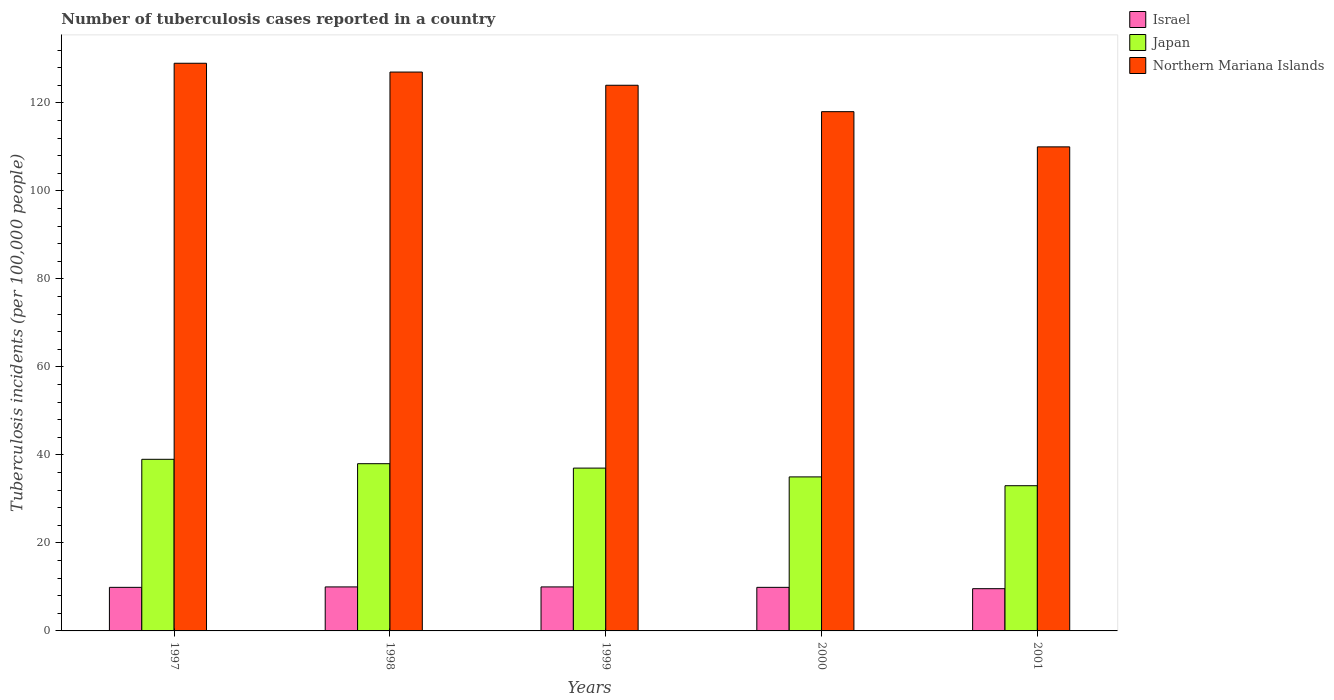How many groups of bars are there?
Provide a succinct answer. 5. Are the number of bars per tick equal to the number of legend labels?
Make the answer very short. Yes. How many bars are there on the 2nd tick from the left?
Your response must be concise. 3. What is the label of the 4th group of bars from the left?
Ensure brevity in your answer.  2000. What is the number of tuberculosis cases reported in in Japan in 1999?
Provide a short and direct response. 37. Across all years, what is the maximum number of tuberculosis cases reported in in Israel?
Provide a short and direct response. 10. Across all years, what is the minimum number of tuberculosis cases reported in in Japan?
Your response must be concise. 33. In which year was the number of tuberculosis cases reported in in Northern Mariana Islands maximum?
Keep it short and to the point. 1997. In which year was the number of tuberculosis cases reported in in Japan minimum?
Give a very brief answer. 2001. What is the total number of tuberculosis cases reported in in Israel in the graph?
Your answer should be compact. 49.4. What is the difference between the number of tuberculosis cases reported in in Northern Mariana Islands in 1997 and that in 1999?
Keep it short and to the point. 5. What is the difference between the number of tuberculosis cases reported in in Japan in 2000 and the number of tuberculosis cases reported in in Northern Mariana Islands in 2001?
Ensure brevity in your answer.  -75. What is the average number of tuberculosis cases reported in in Japan per year?
Offer a terse response. 36.4. In the year 2001, what is the difference between the number of tuberculosis cases reported in in Israel and number of tuberculosis cases reported in in Japan?
Your response must be concise. -23.4. What is the ratio of the number of tuberculosis cases reported in in Japan in 1997 to that in 2001?
Your answer should be compact. 1.18. Is the difference between the number of tuberculosis cases reported in in Israel in 1999 and 2001 greater than the difference between the number of tuberculosis cases reported in in Japan in 1999 and 2001?
Offer a terse response. No. What is the difference between the highest and the second highest number of tuberculosis cases reported in in Japan?
Provide a short and direct response. 1. What is the difference between the highest and the lowest number of tuberculosis cases reported in in Israel?
Offer a very short reply. 0.4. How many bars are there?
Provide a short and direct response. 15. What is the difference between two consecutive major ticks on the Y-axis?
Provide a succinct answer. 20. Where does the legend appear in the graph?
Your response must be concise. Top right. How many legend labels are there?
Provide a short and direct response. 3. How are the legend labels stacked?
Offer a terse response. Vertical. What is the title of the graph?
Provide a short and direct response. Number of tuberculosis cases reported in a country. Does "Caribbean small states" appear as one of the legend labels in the graph?
Make the answer very short. No. What is the label or title of the Y-axis?
Offer a terse response. Tuberculosis incidents (per 100,0 people). What is the Tuberculosis incidents (per 100,000 people) of Israel in 1997?
Your response must be concise. 9.9. What is the Tuberculosis incidents (per 100,000 people) of Japan in 1997?
Provide a short and direct response. 39. What is the Tuberculosis incidents (per 100,000 people) in Northern Mariana Islands in 1997?
Offer a terse response. 129. What is the Tuberculosis incidents (per 100,000 people) in Israel in 1998?
Make the answer very short. 10. What is the Tuberculosis incidents (per 100,000 people) in Northern Mariana Islands in 1998?
Offer a very short reply. 127. What is the Tuberculosis incidents (per 100,000 people) of Japan in 1999?
Offer a very short reply. 37. What is the Tuberculosis incidents (per 100,000 people) in Northern Mariana Islands in 1999?
Provide a succinct answer. 124. What is the Tuberculosis incidents (per 100,000 people) in Northern Mariana Islands in 2000?
Your answer should be very brief. 118. What is the Tuberculosis incidents (per 100,000 people) of Israel in 2001?
Offer a terse response. 9.6. What is the Tuberculosis incidents (per 100,000 people) of Northern Mariana Islands in 2001?
Give a very brief answer. 110. Across all years, what is the maximum Tuberculosis incidents (per 100,000 people) in Japan?
Keep it short and to the point. 39. Across all years, what is the maximum Tuberculosis incidents (per 100,000 people) of Northern Mariana Islands?
Provide a succinct answer. 129. Across all years, what is the minimum Tuberculosis incidents (per 100,000 people) in Israel?
Offer a terse response. 9.6. Across all years, what is the minimum Tuberculosis incidents (per 100,000 people) in Japan?
Your answer should be very brief. 33. Across all years, what is the minimum Tuberculosis incidents (per 100,000 people) of Northern Mariana Islands?
Provide a succinct answer. 110. What is the total Tuberculosis incidents (per 100,000 people) in Israel in the graph?
Ensure brevity in your answer.  49.4. What is the total Tuberculosis incidents (per 100,000 people) of Japan in the graph?
Ensure brevity in your answer.  182. What is the total Tuberculosis incidents (per 100,000 people) in Northern Mariana Islands in the graph?
Provide a succinct answer. 608. What is the difference between the Tuberculosis incidents (per 100,000 people) in Israel in 1997 and that in 1998?
Make the answer very short. -0.1. What is the difference between the Tuberculosis incidents (per 100,000 people) of Northern Mariana Islands in 1997 and that in 1998?
Give a very brief answer. 2. What is the difference between the Tuberculosis incidents (per 100,000 people) in Israel in 1997 and that in 2000?
Provide a short and direct response. 0. What is the difference between the Tuberculosis incidents (per 100,000 people) of Japan in 1997 and that in 2000?
Your answer should be compact. 4. What is the difference between the Tuberculosis incidents (per 100,000 people) in Northern Mariana Islands in 1997 and that in 2000?
Offer a terse response. 11. What is the difference between the Tuberculosis incidents (per 100,000 people) in Israel in 1997 and that in 2001?
Provide a short and direct response. 0.3. What is the difference between the Tuberculosis incidents (per 100,000 people) in Japan in 1997 and that in 2001?
Give a very brief answer. 6. What is the difference between the Tuberculosis incidents (per 100,000 people) in Israel in 1998 and that in 1999?
Offer a terse response. 0. What is the difference between the Tuberculosis incidents (per 100,000 people) in Northern Mariana Islands in 1998 and that in 1999?
Offer a terse response. 3. What is the difference between the Tuberculosis incidents (per 100,000 people) in Israel in 1998 and that in 2000?
Ensure brevity in your answer.  0.1. What is the difference between the Tuberculosis incidents (per 100,000 people) in Israel in 1998 and that in 2001?
Make the answer very short. 0.4. What is the difference between the Tuberculosis incidents (per 100,000 people) of Japan in 1998 and that in 2001?
Keep it short and to the point. 5. What is the difference between the Tuberculosis incidents (per 100,000 people) of Israel in 1999 and that in 2001?
Your response must be concise. 0.4. What is the difference between the Tuberculosis incidents (per 100,000 people) of Japan in 1999 and that in 2001?
Offer a very short reply. 4. What is the difference between the Tuberculosis incidents (per 100,000 people) of Northern Mariana Islands in 1999 and that in 2001?
Your response must be concise. 14. What is the difference between the Tuberculosis incidents (per 100,000 people) in Northern Mariana Islands in 2000 and that in 2001?
Keep it short and to the point. 8. What is the difference between the Tuberculosis incidents (per 100,000 people) in Israel in 1997 and the Tuberculosis incidents (per 100,000 people) in Japan in 1998?
Ensure brevity in your answer.  -28.1. What is the difference between the Tuberculosis incidents (per 100,000 people) in Israel in 1997 and the Tuberculosis incidents (per 100,000 people) in Northern Mariana Islands in 1998?
Give a very brief answer. -117.1. What is the difference between the Tuberculosis incidents (per 100,000 people) in Japan in 1997 and the Tuberculosis incidents (per 100,000 people) in Northern Mariana Islands in 1998?
Your answer should be very brief. -88. What is the difference between the Tuberculosis incidents (per 100,000 people) in Israel in 1997 and the Tuberculosis incidents (per 100,000 people) in Japan in 1999?
Your response must be concise. -27.1. What is the difference between the Tuberculosis incidents (per 100,000 people) in Israel in 1997 and the Tuberculosis incidents (per 100,000 people) in Northern Mariana Islands in 1999?
Provide a short and direct response. -114.1. What is the difference between the Tuberculosis incidents (per 100,000 people) of Japan in 1997 and the Tuberculosis incidents (per 100,000 people) of Northern Mariana Islands in 1999?
Keep it short and to the point. -85. What is the difference between the Tuberculosis incidents (per 100,000 people) of Israel in 1997 and the Tuberculosis incidents (per 100,000 people) of Japan in 2000?
Provide a succinct answer. -25.1. What is the difference between the Tuberculosis incidents (per 100,000 people) in Israel in 1997 and the Tuberculosis incidents (per 100,000 people) in Northern Mariana Islands in 2000?
Offer a very short reply. -108.1. What is the difference between the Tuberculosis incidents (per 100,000 people) of Japan in 1997 and the Tuberculosis incidents (per 100,000 people) of Northern Mariana Islands in 2000?
Provide a short and direct response. -79. What is the difference between the Tuberculosis incidents (per 100,000 people) in Israel in 1997 and the Tuberculosis incidents (per 100,000 people) in Japan in 2001?
Offer a very short reply. -23.1. What is the difference between the Tuberculosis incidents (per 100,000 people) in Israel in 1997 and the Tuberculosis incidents (per 100,000 people) in Northern Mariana Islands in 2001?
Offer a terse response. -100.1. What is the difference between the Tuberculosis incidents (per 100,000 people) in Japan in 1997 and the Tuberculosis incidents (per 100,000 people) in Northern Mariana Islands in 2001?
Provide a short and direct response. -71. What is the difference between the Tuberculosis incidents (per 100,000 people) in Israel in 1998 and the Tuberculosis incidents (per 100,000 people) in Northern Mariana Islands in 1999?
Your response must be concise. -114. What is the difference between the Tuberculosis incidents (per 100,000 people) in Japan in 1998 and the Tuberculosis incidents (per 100,000 people) in Northern Mariana Islands in 1999?
Give a very brief answer. -86. What is the difference between the Tuberculosis incidents (per 100,000 people) in Israel in 1998 and the Tuberculosis incidents (per 100,000 people) in Northern Mariana Islands in 2000?
Your answer should be compact. -108. What is the difference between the Tuberculosis incidents (per 100,000 people) of Japan in 1998 and the Tuberculosis incidents (per 100,000 people) of Northern Mariana Islands in 2000?
Your response must be concise. -80. What is the difference between the Tuberculosis incidents (per 100,000 people) in Israel in 1998 and the Tuberculosis incidents (per 100,000 people) in Northern Mariana Islands in 2001?
Keep it short and to the point. -100. What is the difference between the Tuberculosis incidents (per 100,000 people) in Japan in 1998 and the Tuberculosis incidents (per 100,000 people) in Northern Mariana Islands in 2001?
Your answer should be very brief. -72. What is the difference between the Tuberculosis incidents (per 100,000 people) in Israel in 1999 and the Tuberculosis incidents (per 100,000 people) in Japan in 2000?
Make the answer very short. -25. What is the difference between the Tuberculosis incidents (per 100,000 people) of Israel in 1999 and the Tuberculosis incidents (per 100,000 people) of Northern Mariana Islands in 2000?
Provide a short and direct response. -108. What is the difference between the Tuberculosis incidents (per 100,000 people) in Japan in 1999 and the Tuberculosis incidents (per 100,000 people) in Northern Mariana Islands in 2000?
Provide a short and direct response. -81. What is the difference between the Tuberculosis incidents (per 100,000 people) in Israel in 1999 and the Tuberculosis incidents (per 100,000 people) in Northern Mariana Islands in 2001?
Your answer should be compact. -100. What is the difference between the Tuberculosis incidents (per 100,000 people) in Japan in 1999 and the Tuberculosis incidents (per 100,000 people) in Northern Mariana Islands in 2001?
Your answer should be compact. -73. What is the difference between the Tuberculosis incidents (per 100,000 people) in Israel in 2000 and the Tuberculosis incidents (per 100,000 people) in Japan in 2001?
Your answer should be very brief. -23.1. What is the difference between the Tuberculosis incidents (per 100,000 people) in Israel in 2000 and the Tuberculosis incidents (per 100,000 people) in Northern Mariana Islands in 2001?
Provide a succinct answer. -100.1. What is the difference between the Tuberculosis incidents (per 100,000 people) of Japan in 2000 and the Tuberculosis incidents (per 100,000 people) of Northern Mariana Islands in 2001?
Your response must be concise. -75. What is the average Tuberculosis incidents (per 100,000 people) of Israel per year?
Your answer should be compact. 9.88. What is the average Tuberculosis incidents (per 100,000 people) of Japan per year?
Ensure brevity in your answer.  36.4. What is the average Tuberculosis incidents (per 100,000 people) of Northern Mariana Islands per year?
Your answer should be very brief. 121.6. In the year 1997, what is the difference between the Tuberculosis incidents (per 100,000 people) in Israel and Tuberculosis incidents (per 100,000 people) in Japan?
Make the answer very short. -29.1. In the year 1997, what is the difference between the Tuberculosis incidents (per 100,000 people) of Israel and Tuberculosis incidents (per 100,000 people) of Northern Mariana Islands?
Offer a terse response. -119.1. In the year 1997, what is the difference between the Tuberculosis incidents (per 100,000 people) in Japan and Tuberculosis incidents (per 100,000 people) in Northern Mariana Islands?
Give a very brief answer. -90. In the year 1998, what is the difference between the Tuberculosis incidents (per 100,000 people) of Israel and Tuberculosis incidents (per 100,000 people) of Japan?
Ensure brevity in your answer.  -28. In the year 1998, what is the difference between the Tuberculosis incidents (per 100,000 people) in Israel and Tuberculosis incidents (per 100,000 people) in Northern Mariana Islands?
Offer a very short reply. -117. In the year 1998, what is the difference between the Tuberculosis incidents (per 100,000 people) in Japan and Tuberculosis incidents (per 100,000 people) in Northern Mariana Islands?
Keep it short and to the point. -89. In the year 1999, what is the difference between the Tuberculosis incidents (per 100,000 people) in Israel and Tuberculosis incidents (per 100,000 people) in Northern Mariana Islands?
Give a very brief answer. -114. In the year 1999, what is the difference between the Tuberculosis incidents (per 100,000 people) of Japan and Tuberculosis incidents (per 100,000 people) of Northern Mariana Islands?
Your answer should be compact. -87. In the year 2000, what is the difference between the Tuberculosis incidents (per 100,000 people) in Israel and Tuberculosis incidents (per 100,000 people) in Japan?
Ensure brevity in your answer.  -25.1. In the year 2000, what is the difference between the Tuberculosis incidents (per 100,000 people) of Israel and Tuberculosis incidents (per 100,000 people) of Northern Mariana Islands?
Ensure brevity in your answer.  -108.1. In the year 2000, what is the difference between the Tuberculosis incidents (per 100,000 people) of Japan and Tuberculosis incidents (per 100,000 people) of Northern Mariana Islands?
Offer a very short reply. -83. In the year 2001, what is the difference between the Tuberculosis incidents (per 100,000 people) in Israel and Tuberculosis incidents (per 100,000 people) in Japan?
Give a very brief answer. -23.4. In the year 2001, what is the difference between the Tuberculosis incidents (per 100,000 people) of Israel and Tuberculosis incidents (per 100,000 people) of Northern Mariana Islands?
Your answer should be very brief. -100.4. In the year 2001, what is the difference between the Tuberculosis incidents (per 100,000 people) of Japan and Tuberculosis incidents (per 100,000 people) of Northern Mariana Islands?
Ensure brevity in your answer.  -77. What is the ratio of the Tuberculosis incidents (per 100,000 people) of Japan in 1997 to that in 1998?
Your answer should be very brief. 1.03. What is the ratio of the Tuberculosis incidents (per 100,000 people) of Northern Mariana Islands in 1997 to that in 1998?
Your answer should be compact. 1.02. What is the ratio of the Tuberculosis incidents (per 100,000 people) in Japan in 1997 to that in 1999?
Your answer should be very brief. 1.05. What is the ratio of the Tuberculosis incidents (per 100,000 people) in Northern Mariana Islands in 1997 to that in 1999?
Give a very brief answer. 1.04. What is the ratio of the Tuberculosis incidents (per 100,000 people) of Israel in 1997 to that in 2000?
Provide a succinct answer. 1. What is the ratio of the Tuberculosis incidents (per 100,000 people) in Japan in 1997 to that in 2000?
Keep it short and to the point. 1.11. What is the ratio of the Tuberculosis incidents (per 100,000 people) in Northern Mariana Islands in 1997 to that in 2000?
Provide a short and direct response. 1.09. What is the ratio of the Tuberculosis incidents (per 100,000 people) in Israel in 1997 to that in 2001?
Give a very brief answer. 1.03. What is the ratio of the Tuberculosis incidents (per 100,000 people) of Japan in 1997 to that in 2001?
Keep it short and to the point. 1.18. What is the ratio of the Tuberculosis incidents (per 100,000 people) of Northern Mariana Islands in 1997 to that in 2001?
Provide a short and direct response. 1.17. What is the ratio of the Tuberculosis incidents (per 100,000 people) of Japan in 1998 to that in 1999?
Make the answer very short. 1.03. What is the ratio of the Tuberculosis incidents (per 100,000 people) of Northern Mariana Islands in 1998 to that in 1999?
Provide a short and direct response. 1.02. What is the ratio of the Tuberculosis incidents (per 100,000 people) of Japan in 1998 to that in 2000?
Offer a very short reply. 1.09. What is the ratio of the Tuberculosis incidents (per 100,000 people) of Northern Mariana Islands in 1998 to that in 2000?
Make the answer very short. 1.08. What is the ratio of the Tuberculosis incidents (per 100,000 people) of Israel in 1998 to that in 2001?
Your response must be concise. 1.04. What is the ratio of the Tuberculosis incidents (per 100,000 people) in Japan in 1998 to that in 2001?
Offer a very short reply. 1.15. What is the ratio of the Tuberculosis incidents (per 100,000 people) of Northern Mariana Islands in 1998 to that in 2001?
Offer a terse response. 1.15. What is the ratio of the Tuberculosis incidents (per 100,000 people) of Japan in 1999 to that in 2000?
Your answer should be very brief. 1.06. What is the ratio of the Tuberculosis incidents (per 100,000 people) in Northern Mariana Islands in 1999 to that in 2000?
Offer a very short reply. 1.05. What is the ratio of the Tuberculosis incidents (per 100,000 people) of Israel in 1999 to that in 2001?
Offer a terse response. 1.04. What is the ratio of the Tuberculosis incidents (per 100,000 people) of Japan in 1999 to that in 2001?
Provide a succinct answer. 1.12. What is the ratio of the Tuberculosis incidents (per 100,000 people) of Northern Mariana Islands in 1999 to that in 2001?
Your answer should be compact. 1.13. What is the ratio of the Tuberculosis incidents (per 100,000 people) in Israel in 2000 to that in 2001?
Your response must be concise. 1.03. What is the ratio of the Tuberculosis incidents (per 100,000 people) of Japan in 2000 to that in 2001?
Provide a short and direct response. 1.06. What is the ratio of the Tuberculosis incidents (per 100,000 people) of Northern Mariana Islands in 2000 to that in 2001?
Keep it short and to the point. 1.07. What is the difference between the highest and the second highest Tuberculosis incidents (per 100,000 people) of Israel?
Your answer should be compact. 0. What is the difference between the highest and the second highest Tuberculosis incidents (per 100,000 people) of Northern Mariana Islands?
Provide a succinct answer. 2. 